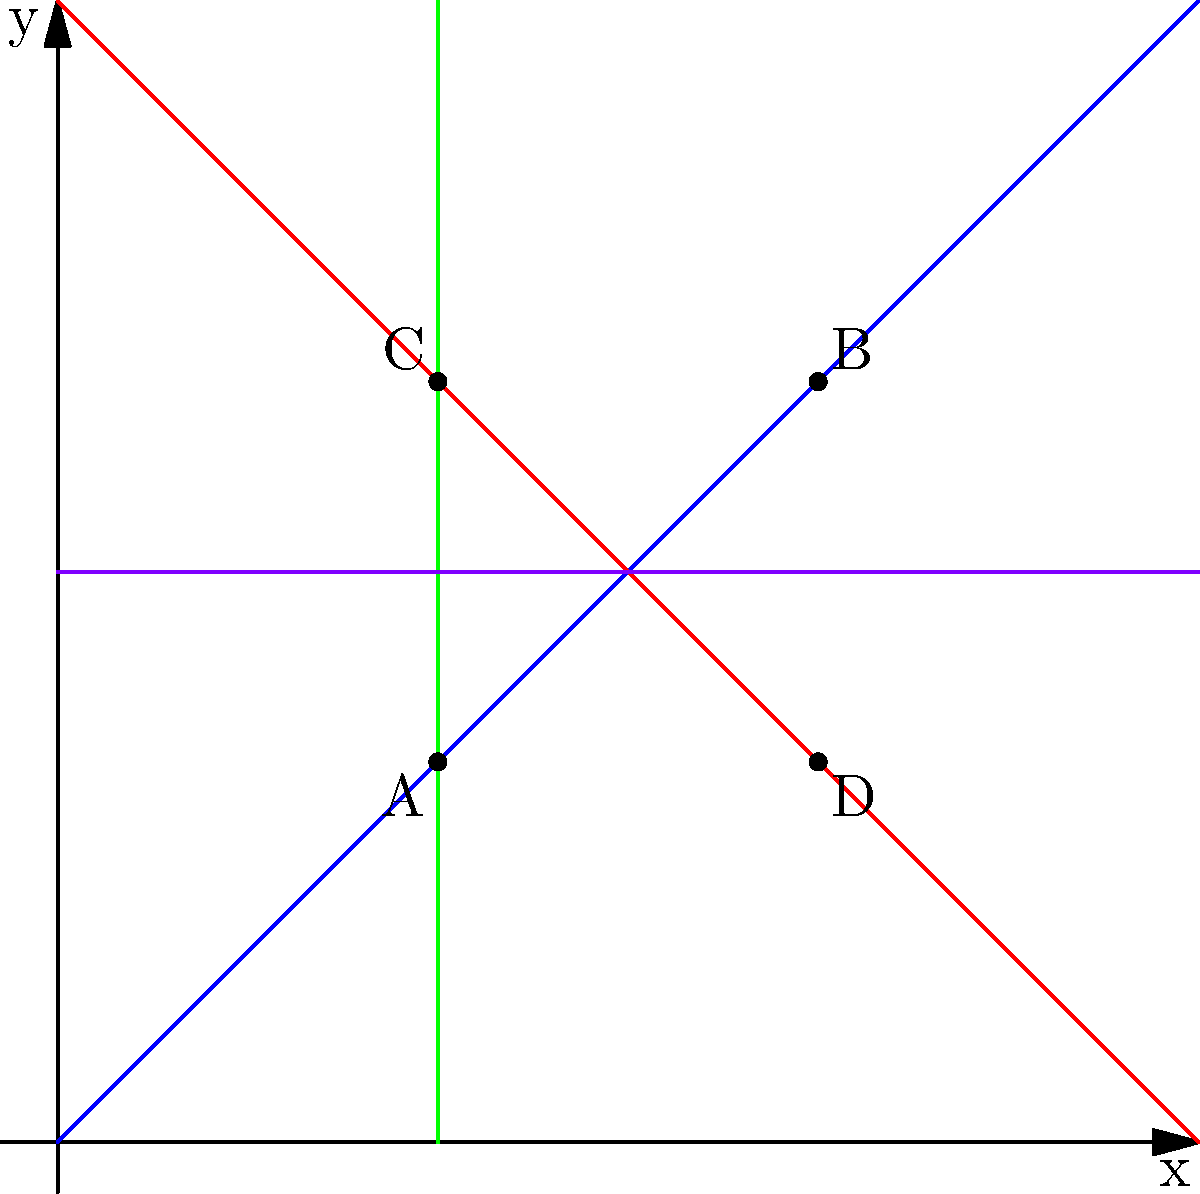In the coordinate plane above, identify which pairs of lines are parallel and which are perpendicular. How can this information be used to create geometric patterns in abstract art? To identify parallel and perpendicular lines, we need to analyze their slopes:

1. Blue line (AB): Slope = $\frac{4-2}{4-2} = 1$
2. Red line (CD): Slope = $\frac{2-4}{4-2} = -1$
3. Green line: Vertical line, undefined slope
4. Purple line: Horizontal line, slope = 0

Parallel lines have the same slope, while perpendicular lines have slopes that are negative reciprocals of each other.

1. The blue and red lines are perpendicular because their slopes multiply to -1: $1 \cdot (-1) = -1$
2. The green and purple lines are perpendicular because one is vertical and the other is horizontal.

There are no parallel lines in this diagram.

In abstract art, understanding parallel and perpendicular lines can be used to:
1. Create balance and symmetry in compositions
2. Develop geometric patterns with consistent angles
3. Establish a sense of structure or grid-like elements
4. Generate visual tension through the interplay of perpendicular lines
5. Design abstract representations of architectural elements or cityscapes
Answer: Blue and red lines are perpendicular; green and purple lines are perpendicular. No parallel lines present. 